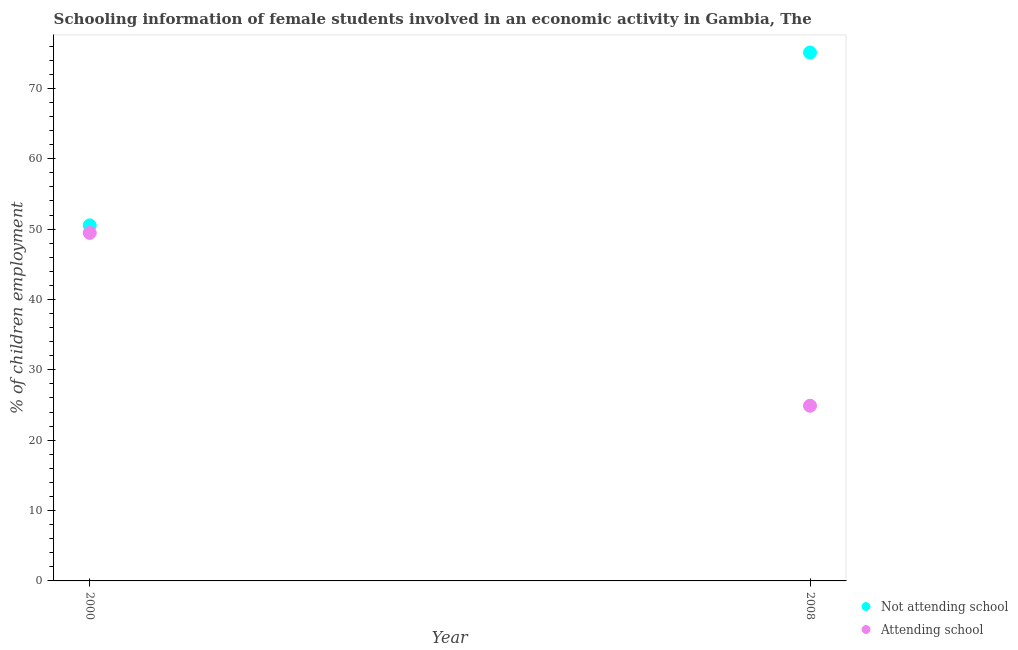How many different coloured dotlines are there?
Provide a short and direct response. 2. What is the percentage of employed females who are not attending school in 2000?
Your answer should be very brief. 50.54. Across all years, what is the maximum percentage of employed females who are not attending school?
Offer a terse response. 75.1. Across all years, what is the minimum percentage of employed females who are not attending school?
Ensure brevity in your answer.  50.54. What is the total percentage of employed females who are not attending school in the graph?
Your answer should be compact. 125.64. What is the difference between the percentage of employed females who are attending school in 2000 and that in 2008?
Your answer should be very brief. 24.56. What is the difference between the percentage of employed females who are not attending school in 2000 and the percentage of employed females who are attending school in 2008?
Your answer should be very brief. 25.64. What is the average percentage of employed females who are attending school per year?
Provide a succinct answer. 37.18. In the year 2008, what is the difference between the percentage of employed females who are attending school and percentage of employed females who are not attending school?
Give a very brief answer. -50.2. What is the ratio of the percentage of employed females who are not attending school in 2000 to that in 2008?
Provide a short and direct response. 0.67. In how many years, is the percentage of employed females who are attending school greater than the average percentage of employed females who are attending school taken over all years?
Keep it short and to the point. 1. Is the percentage of employed females who are attending school strictly greater than the percentage of employed females who are not attending school over the years?
Your answer should be compact. No. Is the percentage of employed females who are not attending school strictly less than the percentage of employed females who are attending school over the years?
Offer a very short reply. No. How many years are there in the graph?
Your answer should be very brief. 2. What is the difference between two consecutive major ticks on the Y-axis?
Offer a terse response. 10. Are the values on the major ticks of Y-axis written in scientific E-notation?
Give a very brief answer. No. Does the graph contain any zero values?
Your answer should be very brief. No. Does the graph contain grids?
Your answer should be very brief. No. Where does the legend appear in the graph?
Your answer should be compact. Bottom right. What is the title of the graph?
Offer a very short reply. Schooling information of female students involved in an economic activity in Gambia, The. Does "Register a property" appear as one of the legend labels in the graph?
Ensure brevity in your answer.  No. What is the label or title of the X-axis?
Offer a terse response. Year. What is the label or title of the Y-axis?
Your answer should be compact. % of children employment. What is the % of children employment of Not attending school in 2000?
Make the answer very short. 50.54. What is the % of children employment in Attending school in 2000?
Your answer should be compact. 49.46. What is the % of children employment of Not attending school in 2008?
Make the answer very short. 75.1. What is the % of children employment of Attending school in 2008?
Offer a very short reply. 24.9. Across all years, what is the maximum % of children employment in Not attending school?
Provide a succinct answer. 75.1. Across all years, what is the maximum % of children employment of Attending school?
Ensure brevity in your answer.  49.46. Across all years, what is the minimum % of children employment of Not attending school?
Offer a terse response. 50.54. Across all years, what is the minimum % of children employment of Attending school?
Your answer should be compact. 24.9. What is the total % of children employment in Not attending school in the graph?
Your answer should be compact. 125.64. What is the total % of children employment in Attending school in the graph?
Offer a terse response. 74.36. What is the difference between the % of children employment of Not attending school in 2000 and that in 2008?
Provide a succinct answer. -24.56. What is the difference between the % of children employment in Attending school in 2000 and that in 2008?
Your answer should be very brief. 24.56. What is the difference between the % of children employment of Not attending school in 2000 and the % of children employment of Attending school in 2008?
Provide a succinct answer. 25.64. What is the average % of children employment in Not attending school per year?
Give a very brief answer. 62.82. What is the average % of children employment of Attending school per year?
Keep it short and to the point. 37.18. In the year 2000, what is the difference between the % of children employment of Not attending school and % of children employment of Attending school?
Provide a succinct answer. 1.07. In the year 2008, what is the difference between the % of children employment in Not attending school and % of children employment in Attending school?
Offer a terse response. 50.2. What is the ratio of the % of children employment in Not attending school in 2000 to that in 2008?
Your answer should be very brief. 0.67. What is the ratio of the % of children employment of Attending school in 2000 to that in 2008?
Keep it short and to the point. 1.99. What is the difference between the highest and the second highest % of children employment in Not attending school?
Your answer should be very brief. 24.56. What is the difference between the highest and the second highest % of children employment of Attending school?
Ensure brevity in your answer.  24.56. What is the difference between the highest and the lowest % of children employment of Not attending school?
Ensure brevity in your answer.  24.56. What is the difference between the highest and the lowest % of children employment of Attending school?
Offer a very short reply. 24.56. 